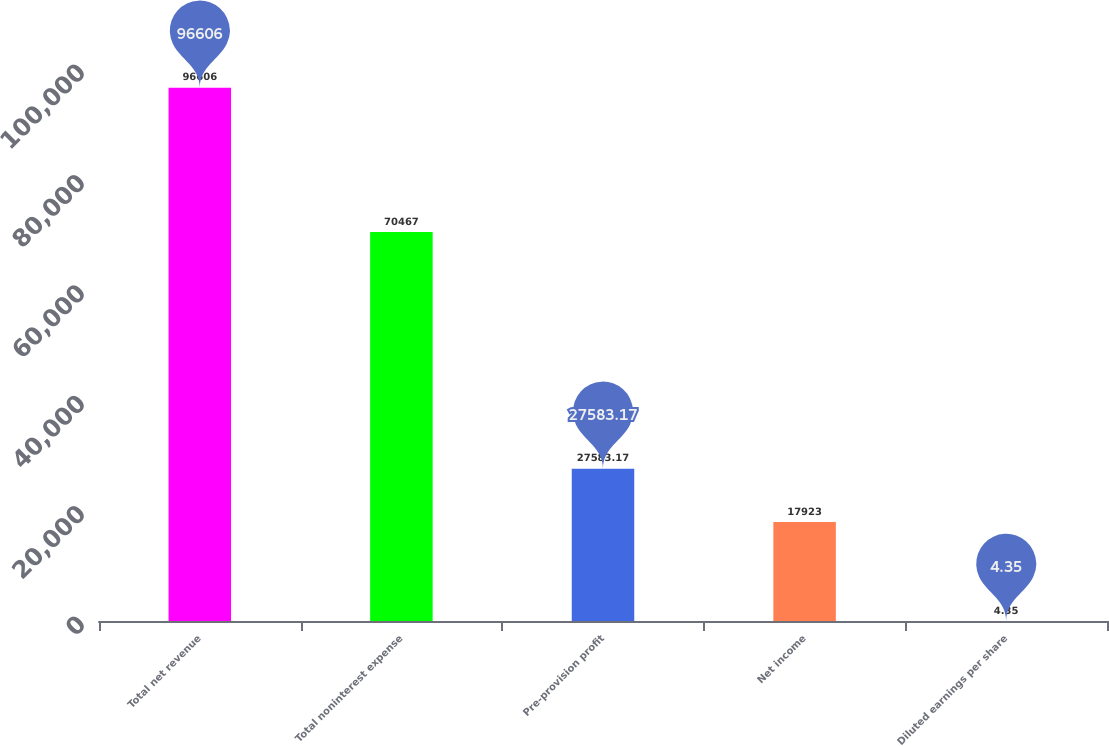<chart> <loc_0><loc_0><loc_500><loc_500><bar_chart><fcel>Total net revenue<fcel>Total noninterest expense<fcel>Pre-provision profit<fcel>Net income<fcel>Diluted earnings per share<nl><fcel>96606<fcel>70467<fcel>27583.2<fcel>17923<fcel>4.35<nl></chart> 